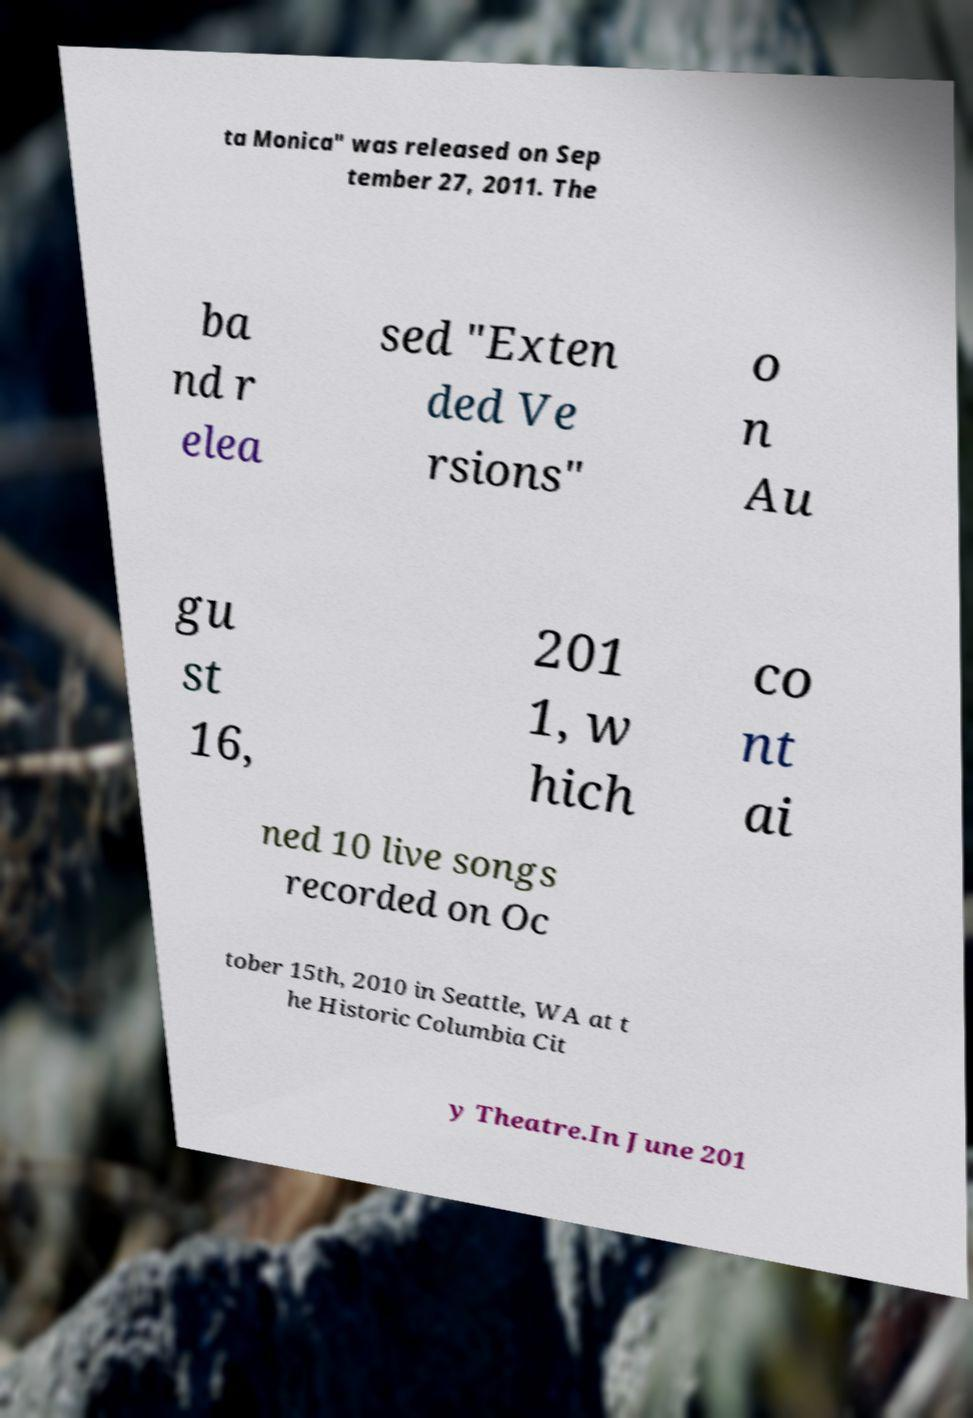Could you extract and type out the text from this image? ta Monica" was released on Sep tember 27, 2011. The ba nd r elea sed "Exten ded Ve rsions" o n Au gu st 16, 201 1, w hich co nt ai ned 10 live songs recorded on Oc tober 15th, 2010 in Seattle, WA at t he Historic Columbia Cit y Theatre.In June 201 